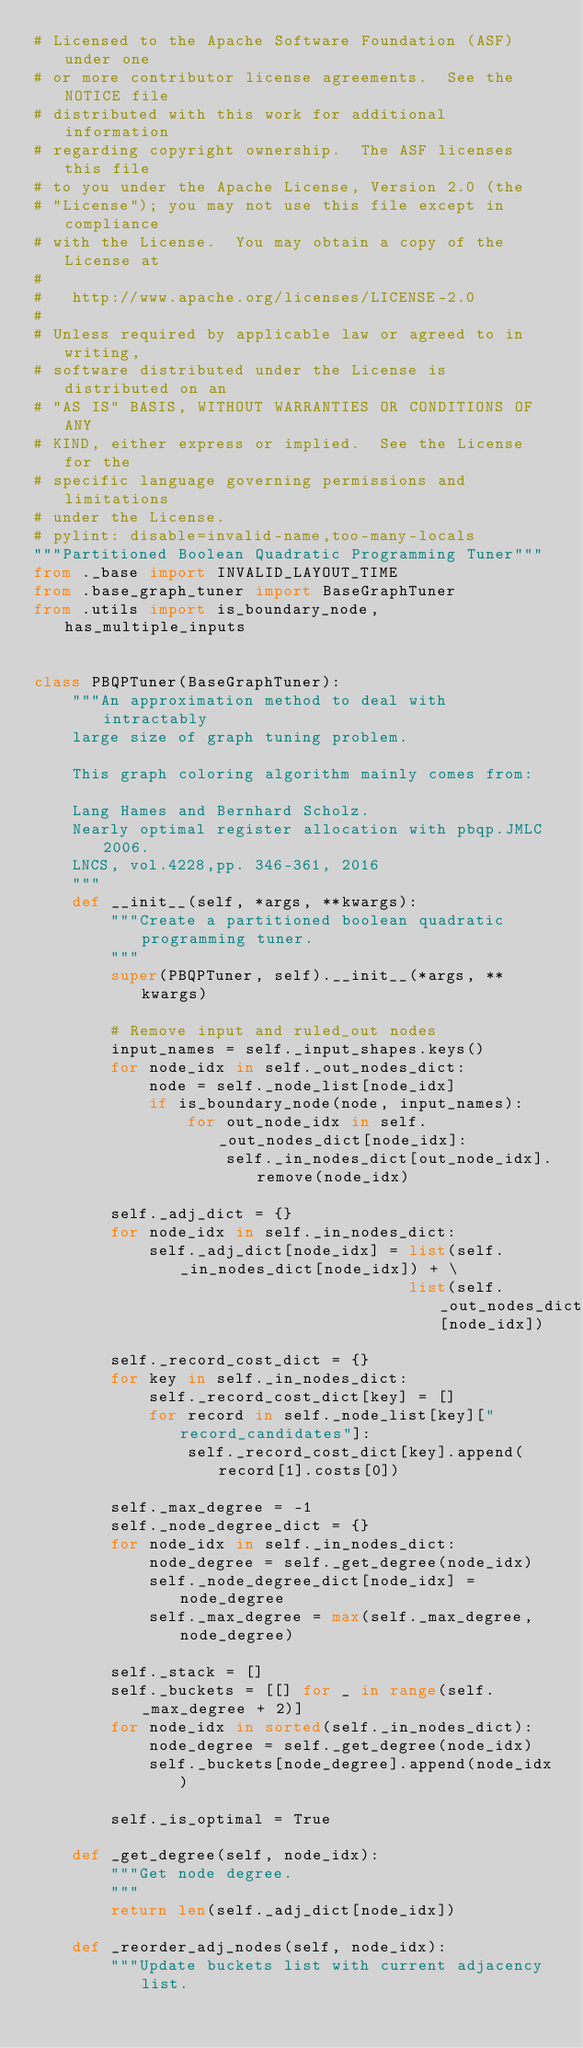<code> <loc_0><loc_0><loc_500><loc_500><_Python_># Licensed to the Apache Software Foundation (ASF) under one
# or more contributor license agreements.  See the NOTICE file
# distributed with this work for additional information
# regarding copyright ownership.  The ASF licenses this file
# to you under the Apache License, Version 2.0 (the
# "License"); you may not use this file except in compliance
# with the License.  You may obtain a copy of the License at
#
#   http://www.apache.org/licenses/LICENSE-2.0
#
# Unless required by applicable law or agreed to in writing,
# software distributed under the License is distributed on an
# "AS IS" BASIS, WITHOUT WARRANTIES OR CONDITIONS OF ANY
# KIND, either express or implied.  See the License for the
# specific language governing permissions and limitations
# under the License.
# pylint: disable=invalid-name,too-many-locals
"""Partitioned Boolean Quadratic Programming Tuner"""
from ._base import INVALID_LAYOUT_TIME
from .base_graph_tuner import BaseGraphTuner
from .utils import is_boundary_node, has_multiple_inputs


class PBQPTuner(BaseGraphTuner):
    """An approximation method to deal with intractably
    large size of graph tuning problem.

    This graph coloring algorithm mainly comes from:

    Lang Hames and Bernhard Scholz.
    Nearly optimal register allocation with pbqp.JMLC 2006.
    LNCS, vol.4228,pp. 346-361, 2016
    """
    def __init__(self, *args, **kwargs):
        """Create a partitioned boolean quadratic programming tuner.
        """
        super(PBQPTuner, self).__init__(*args, **kwargs)

        # Remove input and ruled_out nodes
        input_names = self._input_shapes.keys()
        for node_idx in self._out_nodes_dict:
            node = self._node_list[node_idx]
            if is_boundary_node(node, input_names):
                for out_node_idx in self._out_nodes_dict[node_idx]:
                    self._in_nodes_dict[out_node_idx].remove(node_idx)

        self._adj_dict = {}
        for node_idx in self._in_nodes_dict:
            self._adj_dict[node_idx] = list(self._in_nodes_dict[node_idx]) + \
                                       list(self._out_nodes_dict[node_idx])

        self._record_cost_dict = {}
        for key in self._in_nodes_dict:
            self._record_cost_dict[key] = []
            for record in self._node_list[key]["record_candidates"]:
                self._record_cost_dict[key].append(record[1].costs[0])

        self._max_degree = -1
        self._node_degree_dict = {}
        for node_idx in self._in_nodes_dict:
            node_degree = self._get_degree(node_idx)
            self._node_degree_dict[node_idx] = node_degree
            self._max_degree = max(self._max_degree, node_degree)

        self._stack = []
        self._buckets = [[] for _ in range(self._max_degree + 2)]
        for node_idx in sorted(self._in_nodes_dict):
            node_degree = self._get_degree(node_idx)
            self._buckets[node_degree].append(node_idx)

        self._is_optimal = True

    def _get_degree(self, node_idx):
        """Get node degree.
        """
        return len(self._adj_dict[node_idx])

    def _reorder_adj_nodes(self, node_idx):
        """Update buckets list with current adjacency list.</code> 